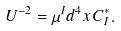Convert formula to latex. <formula><loc_0><loc_0><loc_500><loc_500>U ^ { - 2 } = \mu ^ { I } d ^ { 4 } x \, C ^ { * } _ { I } .</formula> 